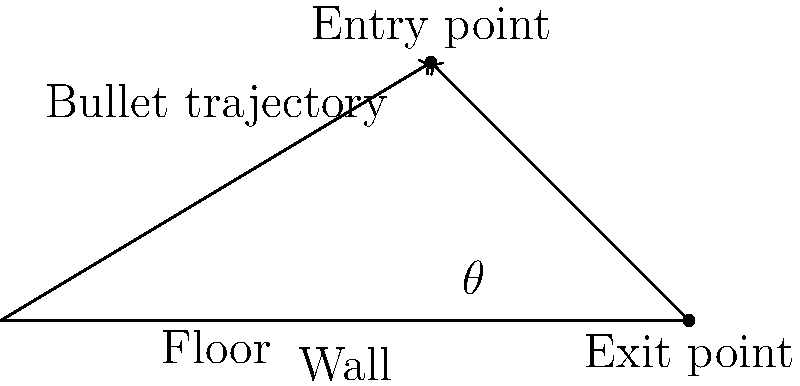In the crime scene sketch above, a bullet has entered a wall at point B and exited at point C. The floor is represented by the line AC. If the distance AC is 8 feet and the height of the entry point (AB) is 3 feet, what is the angle $\theta$ between the bullet's trajectory and the floor? To find the angle $\theta$ between the bullet's trajectory and the floor, we can follow these steps:

1. Identify the right triangle formed by the bullet's path and the floor.
2. Use the inverse tangent (arctan) function to calculate the angle.

Step 1: Identify the right triangle
- The hypotenuse of the triangle is the bullet's trajectory (BC).
- The base of the triangle is the distance along the floor from the exit point to directly below the entry point (AC - AB = 8 - 5 = 3 feet).
- The height of the triangle is the entry point height (3 feet).

Step 2: Calculate the angle using arctan
- In a right triangle, $\tan(\theta) = \frac{\text{opposite}}{\text{adjacent}}$
- Here, $\tan(\theta) = \frac{3}{3} = 1$
- To find $\theta$, we use the inverse tangent function:
  $\theta = \arctan(1)$

Step 3: Convert the result to degrees
- $\theta = \arctan(1) \approx 0.7853981634$ radians
- Convert to degrees: $0.7853981634 \times \frac{180°}{\pi} \approx 45°$

Therefore, the angle $\theta$ between the bullet's trajectory and the floor is approximately 45°.
Answer: 45° 